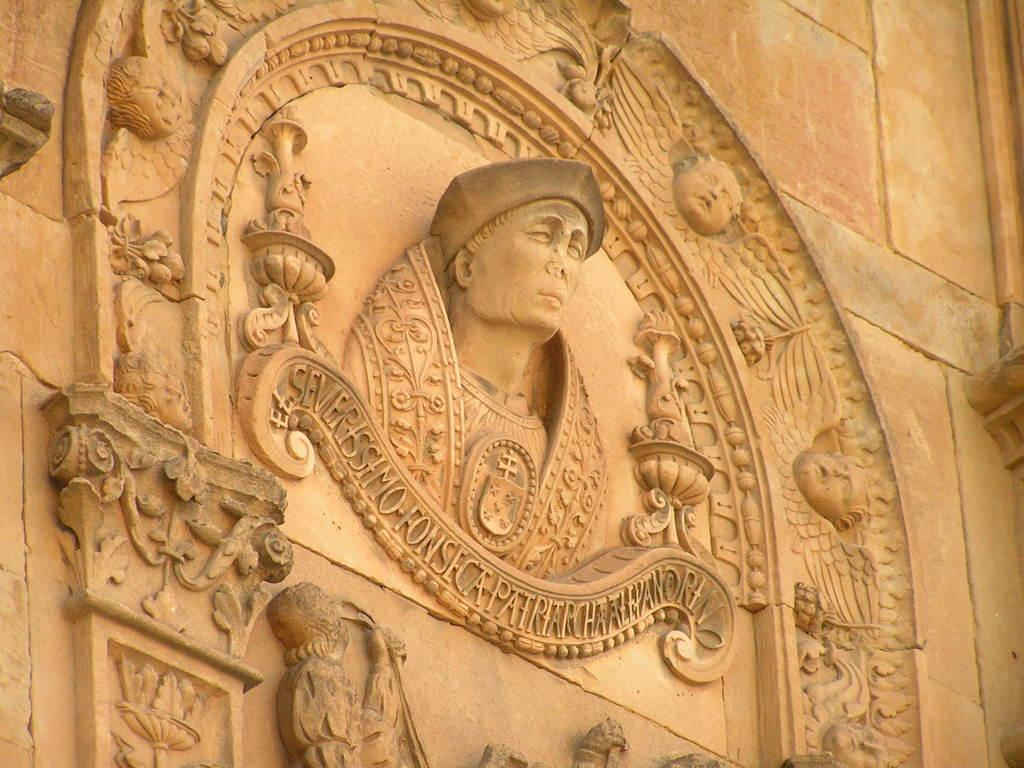What type of structure is featured in the image? There is a historical building in the image. What can be seen on the building wall? The building wall has sculptures on it, and the sculptures depict a person. Is there any text visible on the building wall? Yes, there is writing on the building wall. How many chairs can be seen in the image? There are no chairs present in the image. Is there a ship visible in the image? No, there is no ship present in the image. 